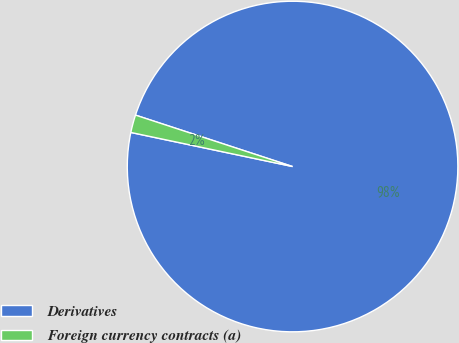Convert chart. <chart><loc_0><loc_0><loc_500><loc_500><pie_chart><fcel>Derivatives<fcel>Foreign currency contracts (a)<nl><fcel>98.27%<fcel>1.73%<nl></chart> 